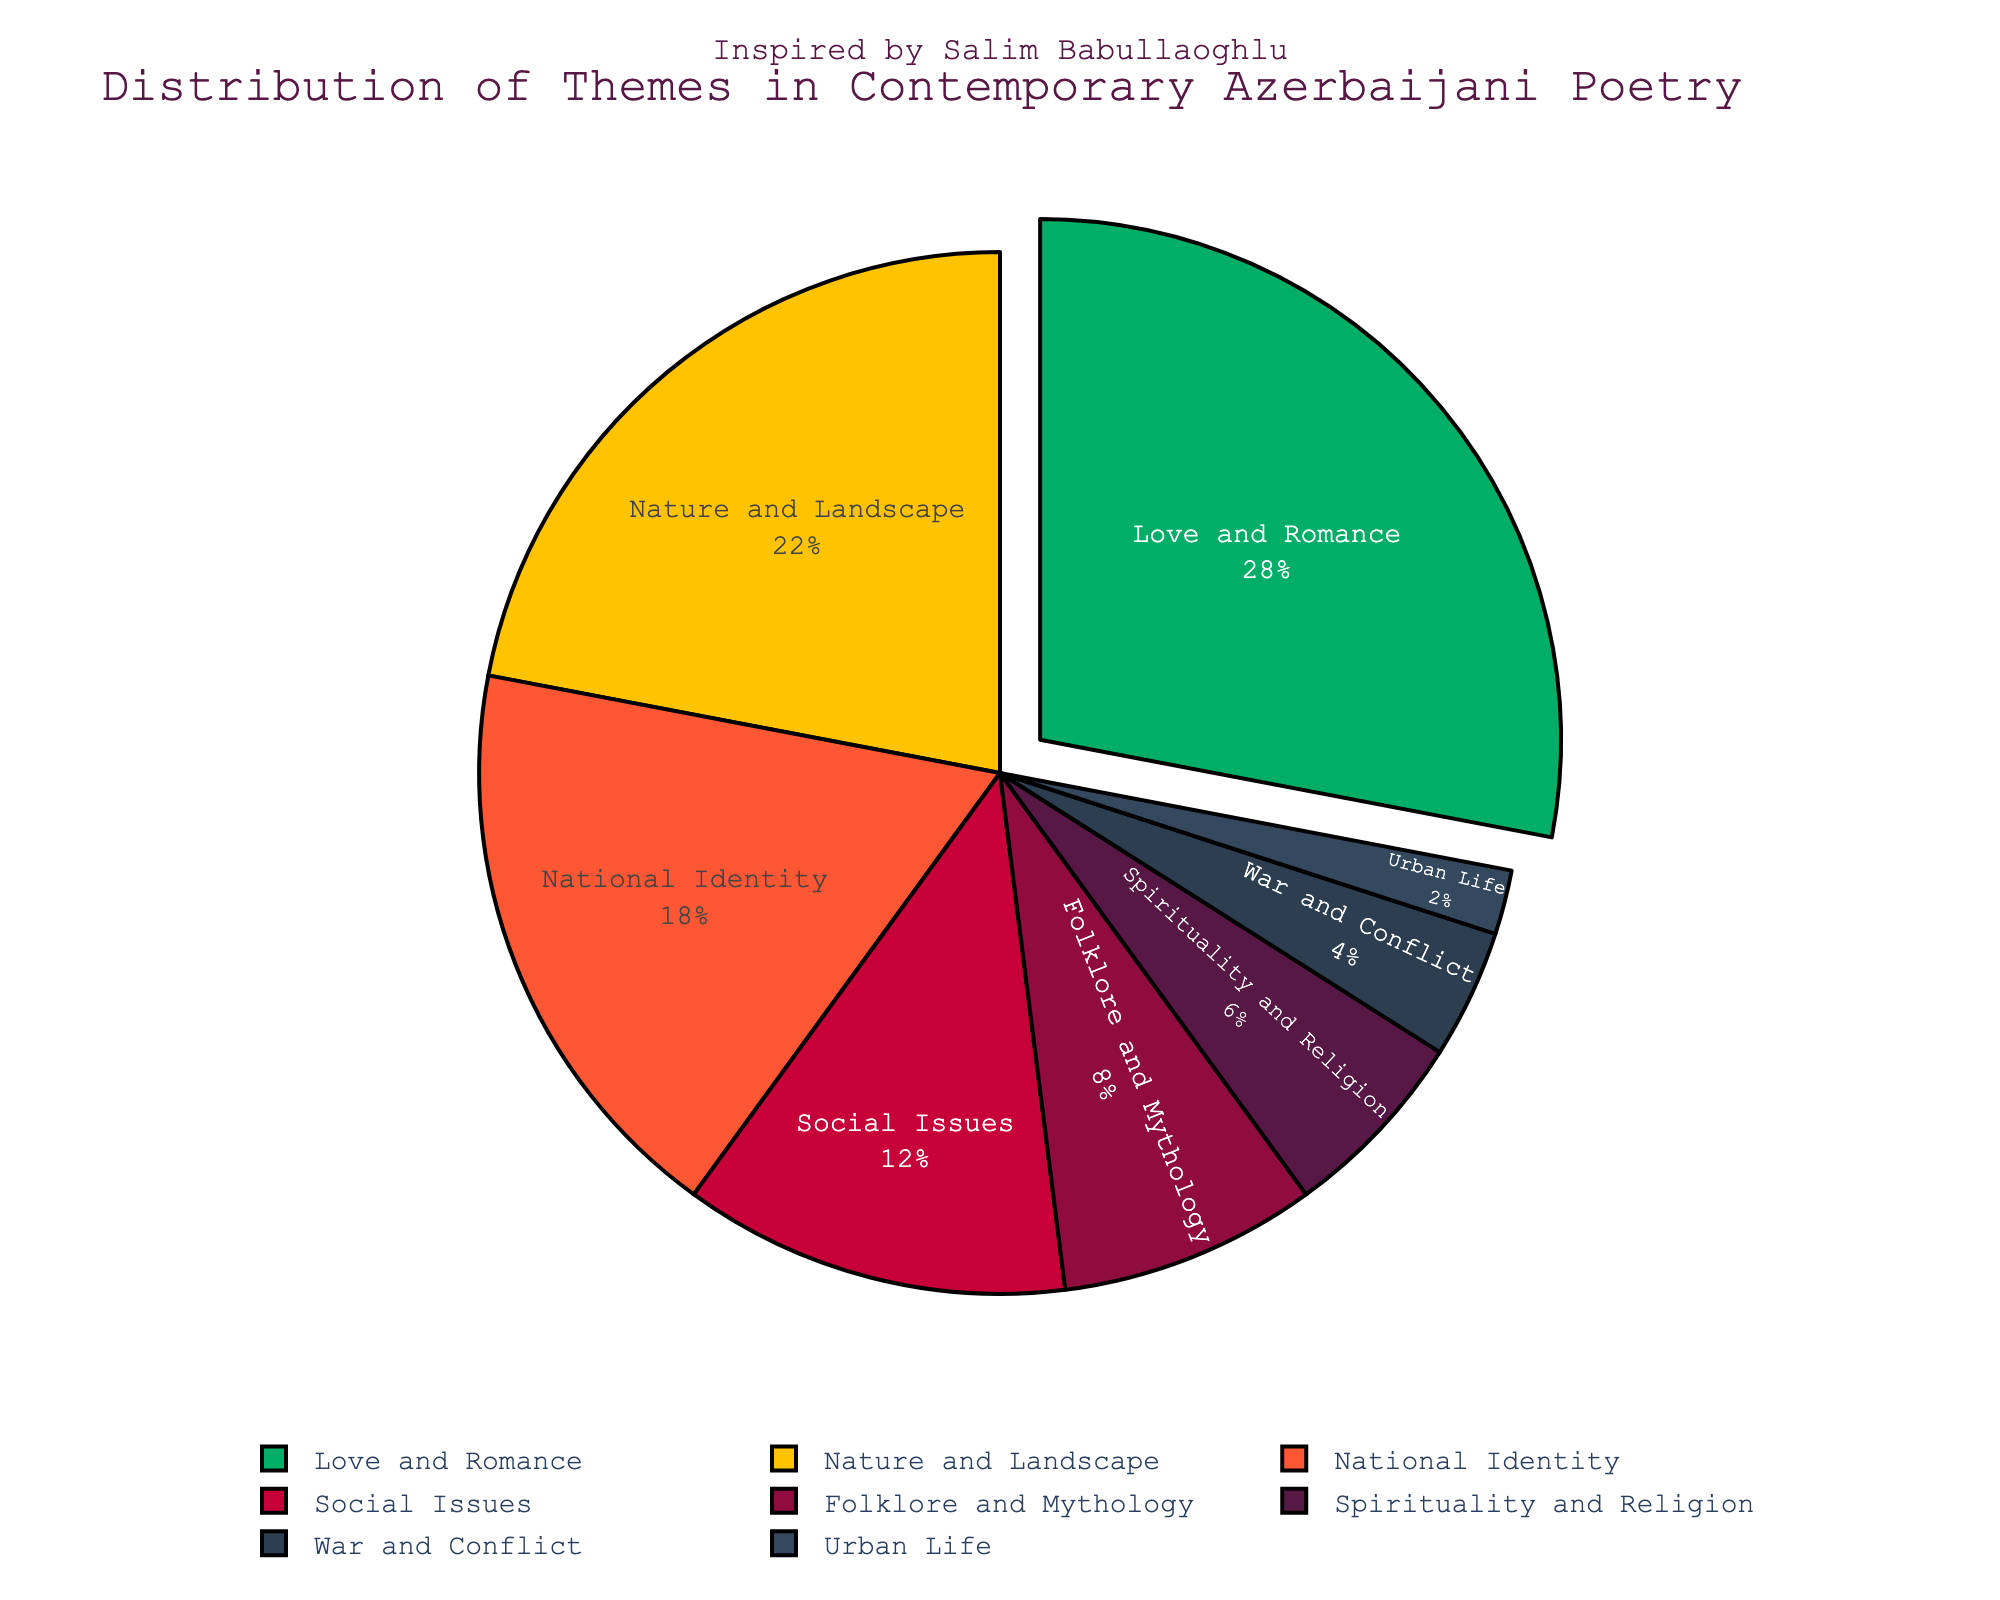What is the most common theme in contemporary Azerbaijani poetry? The pie chart shows that the largest section of the pie corresponds to "Love and Romance" at 28%, indicating it is the most common theme.
Answer: Love and Romance Which two themes together make up half of the themes in contemporary Azerbaijani poetry? Adding the percentages of "Love and Romance" (28%) and "Nature and Landscape" (22%) gives us 50%.
Answer: Love and Romance and Nature and Landscape What theme covers the smallest portion of contemporary Azerbaijani poetry? The smallest section of the pie chart belongs to "Urban Life" at 2%, making it the least covered theme.
Answer: Urban Life If you combine the percentages of National Identity and Social Issues, does it surpass the percentage of Love and Romance? The percentages for National Identity (18%) and Social Issues (12%) together add up to 30%, which is greater than the 28% for Love and Romance.
Answer: Yes Which themes account for more than 20% each? By observing the pie chart, only "Love and Romance" (28%) and "Nature and Landscape" (22%) individually account for more than 20%.
Answer: Love and Romance and Nature and Landscape How much more common is "Love and Romance" compared to "Spirituality and Religion"? Subtracting the percentage of "Spirituality and Religion" (6%) from "Love and Romance" (28%) gives us 22%.
Answer: 22% What is the total percentage representation of themes related to society (National Identity, Social Issues, and Urban Life)? Adding the percentages of National Identity (18%), Social Issues (12%), and Urban Life (2%), we get 32%.
Answer: 32% Which visual feature indicates the most prominent theme in the pie chart? The slice corresponding to the most prominent theme, "Love and Romance," is slightly pulled out from the rest of the pie for emphasis.
Answer: The slice is pulled out Is "National Identity" more or less prevalent than "Nature and Landscape"? The percentage for "National Identity" is 18%, which is less than "Nature and Landscape" at 22%.
Answer: Less What proportion of the poetry themes deal with spiritual or folk elements when combined? Adding the percentages for "Spirituality and Religion" (6%) and "Folklore and Mythology" (8%), we get 14%.
Answer: 14% 